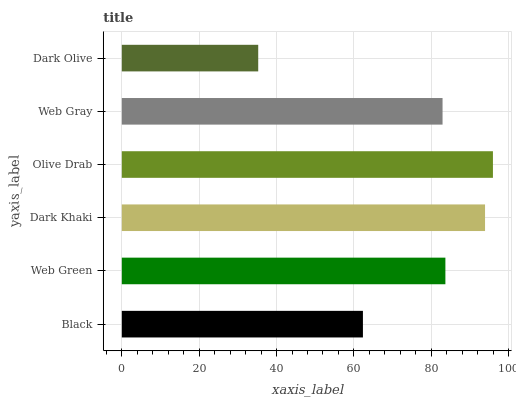Is Dark Olive the minimum?
Answer yes or no. Yes. Is Olive Drab the maximum?
Answer yes or no. Yes. Is Web Green the minimum?
Answer yes or no. No. Is Web Green the maximum?
Answer yes or no. No. Is Web Green greater than Black?
Answer yes or no. Yes. Is Black less than Web Green?
Answer yes or no. Yes. Is Black greater than Web Green?
Answer yes or no. No. Is Web Green less than Black?
Answer yes or no. No. Is Web Green the high median?
Answer yes or no. Yes. Is Web Gray the low median?
Answer yes or no. Yes. Is Web Gray the high median?
Answer yes or no. No. Is Olive Drab the low median?
Answer yes or no. No. 